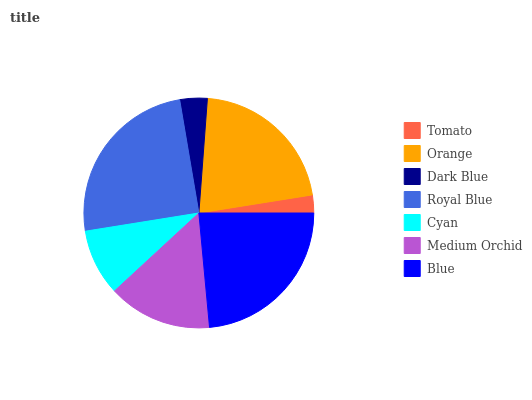Is Tomato the minimum?
Answer yes or no. Yes. Is Royal Blue the maximum?
Answer yes or no. Yes. Is Orange the minimum?
Answer yes or no. No. Is Orange the maximum?
Answer yes or no. No. Is Orange greater than Tomato?
Answer yes or no. Yes. Is Tomato less than Orange?
Answer yes or no. Yes. Is Tomato greater than Orange?
Answer yes or no. No. Is Orange less than Tomato?
Answer yes or no. No. Is Medium Orchid the high median?
Answer yes or no. Yes. Is Medium Orchid the low median?
Answer yes or no. Yes. Is Blue the high median?
Answer yes or no. No. Is Orange the low median?
Answer yes or no. No. 